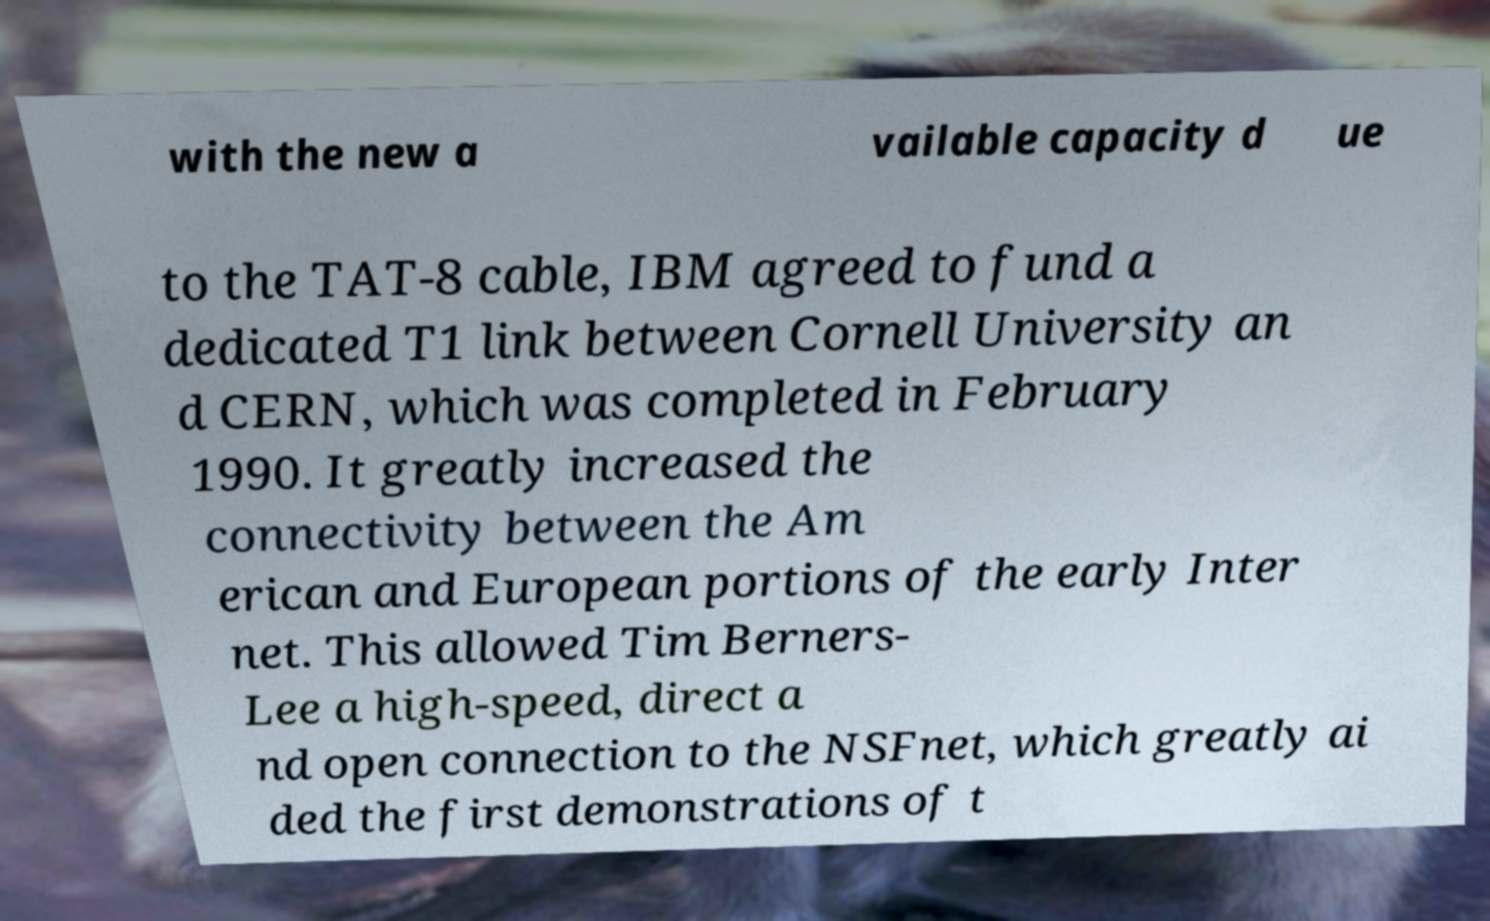For documentation purposes, I need the text within this image transcribed. Could you provide that? with the new a vailable capacity d ue to the TAT-8 cable, IBM agreed to fund a dedicated T1 link between Cornell University an d CERN, which was completed in February 1990. It greatly increased the connectivity between the Am erican and European portions of the early Inter net. This allowed Tim Berners- Lee a high-speed, direct a nd open connection to the NSFnet, which greatly ai ded the first demonstrations of t 